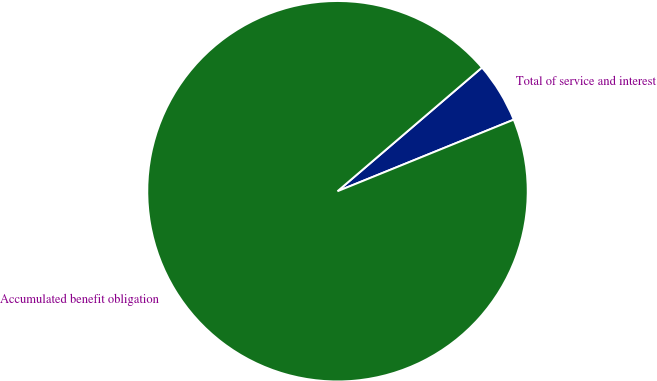<chart> <loc_0><loc_0><loc_500><loc_500><pie_chart><fcel>Total of service and interest<fcel>Accumulated benefit obligation<nl><fcel>5.13%<fcel>94.87%<nl></chart> 